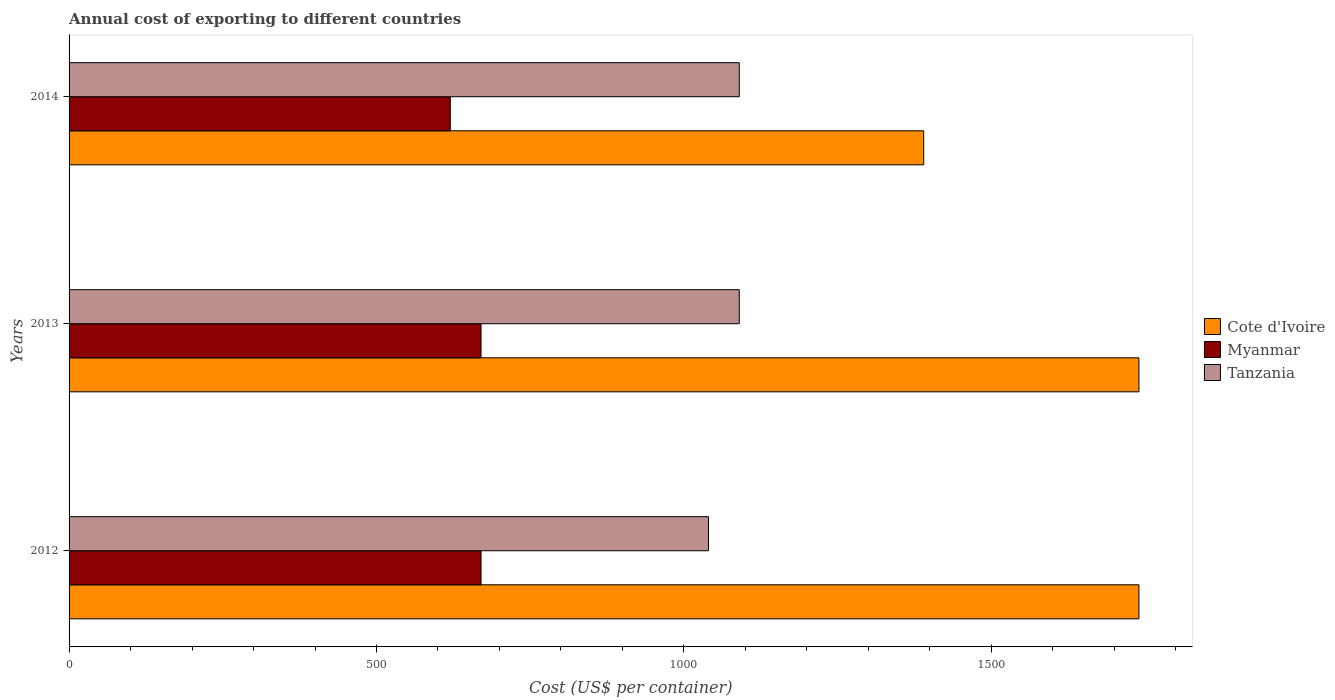What is the label of the 3rd group of bars from the top?
Offer a terse response. 2012. In how many cases, is the number of bars for a given year not equal to the number of legend labels?
Provide a succinct answer. 0. What is the total annual cost of exporting in Cote d'Ivoire in 2013?
Keep it short and to the point. 1740. Across all years, what is the maximum total annual cost of exporting in Tanzania?
Ensure brevity in your answer.  1090. Across all years, what is the minimum total annual cost of exporting in Myanmar?
Make the answer very short. 620. In which year was the total annual cost of exporting in Cote d'Ivoire minimum?
Provide a succinct answer. 2014. What is the total total annual cost of exporting in Cote d'Ivoire in the graph?
Offer a terse response. 4870. What is the difference between the total annual cost of exporting in Tanzania in 2012 and that in 2013?
Your response must be concise. -50. What is the difference between the total annual cost of exporting in Myanmar in 2014 and the total annual cost of exporting in Cote d'Ivoire in 2012?
Offer a terse response. -1120. What is the average total annual cost of exporting in Myanmar per year?
Offer a terse response. 653.33. In the year 2014, what is the difference between the total annual cost of exporting in Myanmar and total annual cost of exporting in Cote d'Ivoire?
Provide a short and direct response. -770. In how many years, is the total annual cost of exporting in Cote d'Ivoire greater than 200 US$?
Keep it short and to the point. 3. What is the ratio of the total annual cost of exporting in Myanmar in 2013 to that in 2014?
Your response must be concise. 1.08. What is the difference between the highest and the lowest total annual cost of exporting in Cote d'Ivoire?
Keep it short and to the point. 350. Is the sum of the total annual cost of exporting in Tanzania in 2012 and 2013 greater than the maximum total annual cost of exporting in Cote d'Ivoire across all years?
Keep it short and to the point. Yes. What does the 2nd bar from the top in 2012 represents?
Your answer should be very brief. Myanmar. What does the 3rd bar from the bottom in 2014 represents?
Ensure brevity in your answer.  Tanzania. How many bars are there?
Ensure brevity in your answer.  9. What is the difference between two consecutive major ticks on the X-axis?
Give a very brief answer. 500. Does the graph contain any zero values?
Provide a short and direct response. No. How many legend labels are there?
Your answer should be very brief. 3. What is the title of the graph?
Your response must be concise. Annual cost of exporting to different countries. Does "Somalia" appear as one of the legend labels in the graph?
Give a very brief answer. No. What is the label or title of the X-axis?
Your answer should be compact. Cost (US$ per container). What is the Cost (US$ per container) of Cote d'Ivoire in 2012?
Your answer should be compact. 1740. What is the Cost (US$ per container) of Myanmar in 2012?
Your response must be concise. 670. What is the Cost (US$ per container) of Tanzania in 2012?
Give a very brief answer. 1040. What is the Cost (US$ per container) in Cote d'Ivoire in 2013?
Ensure brevity in your answer.  1740. What is the Cost (US$ per container) in Myanmar in 2013?
Keep it short and to the point. 670. What is the Cost (US$ per container) in Tanzania in 2013?
Your answer should be very brief. 1090. What is the Cost (US$ per container) in Cote d'Ivoire in 2014?
Make the answer very short. 1390. What is the Cost (US$ per container) of Myanmar in 2014?
Ensure brevity in your answer.  620. What is the Cost (US$ per container) of Tanzania in 2014?
Offer a terse response. 1090. Across all years, what is the maximum Cost (US$ per container) in Cote d'Ivoire?
Offer a very short reply. 1740. Across all years, what is the maximum Cost (US$ per container) of Myanmar?
Provide a succinct answer. 670. Across all years, what is the maximum Cost (US$ per container) in Tanzania?
Make the answer very short. 1090. Across all years, what is the minimum Cost (US$ per container) in Cote d'Ivoire?
Keep it short and to the point. 1390. Across all years, what is the minimum Cost (US$ per container) in Myanmar?
Your answer should be very brief. 620. Across all years, what is the minimum Cost (US$ per container) in Tanzania?
Your answer should be compact. 1040. What is the total Cost (US$ per container) in Cote d'Ivoire in the graph?
Your answer should be very brief. 4870. What is the total Cost (US$ per container) of Myanmar in the graph?
Your answer should be very brief. 1960. What is the total Cost (US$ per container) in Tanzania in the graph?
Offer a very short reply. 3220. What is the difference between the Cost (US$ per container) of Tanzania in 2012 and that in 2013?
Make the answer very short. -50. What is the difference between the Cost (US$ per container) in Cote d'Ivoire in 2012 and that in 2014?
Provide a succinct answer. 350. What is the difference between the Cost (US$ per container) in Myanmar in 2012 and that in 2014?
Ensure brevity in your answer.  50. What is the difference between the Cost (US$ per container) of Cote d'Ivoire in 2013 and that in 2014?
Offer a very short reply. 350. What is the difference between the Cost (US$ per container) in Myanmar in 2013 and that in 2014?
Your answer should be very brief. 50. What is the difference between the Cost (US$ per container) of Tanzania in 2013 and that in 2014?
Keep it short and to the point. 0. What is the difference between the Cost (US$ per container) in Cote d'Ivoire in 2012 and the Cost (US$ per container) in Myanmar in 2013?
Your response must be concise. 1070. What is the difference between the Cost (US$ per container) of Cote d'Ivoire in 2012 and the Cost (US$ per container) of Tanzania in 2013?
Ensure brevity in your answer.  650. What is the difference between the Cost (US$ per container) in Myanmar in 2012 and the Cost (US$ per container) in Tanzania in 2013?
Ensure brevity in your answer.  -420. What is the difference between the Cost (US$ per container) of Cote d'Ivoire in 2012 and the Cost (US$ per container) of Myanmar in 2014?
Provide a short and direct response. 1120. What is the difference between the Cost (US$ per container) in Cote d'Ivoire in 2012 and the Cost (US$ per container) in Tanzania in 2014?
Offer a very short reply. 650. What is the difference between the Cost (US$ per container) of Myanmar in 2012 and the Cost (US$ per container) of Tanzania in 2014?
Offer a very short reply. -420. What is the difference between the Cost (US$ per container) of Cote d'Ivoire in 2013 and the Cost (US$ per container) of Myanmar in 2014?
Your answer should be compact. 1120. What is the difference between the Cost (US$ per container) in Cote d'Ivoire in 2013 and the Cost (US$ per container) in Tanzania in 2014?
Provide a short and direct response. 650. What is the difference between the Cost (US$ per container) in Myanmar in 2013 and the Cost (US$ per container) in Tanzania in 2014?
Ensure brevity in your answer.  -420. What is the average Cost (US$ per container) of Cote d'Ivoire per year?
Give a very brief answer. 1623.33. What is the average Cost (US$ per container) in Myanmar per year?
Offer a terse response. 653.33. What is the average Cost (US$ per container) of Tanzania per year?
Offer a very short reply. 1073.33. In the year 2012, what is the difference between the Cost (US$ per container) in Cote d'Ivoire and Cost (US$ per container) in Myanmar?
Your answer should be compact. 1070. In the year 2012, what is the difference between the Cost (US$ per container) in Cote d'Ivoire and Cost (US$ per container) in Tanzania?
Keep it short and to the point. 700. In the year 2012, what is the difference between the Cost (US$ per container) of Myanmar and Cost (US$ per container) of Tanzania?
Keep it short and to the point. -370. In the year 2013, what is the difference between the Cost (US$ per container) of Cote d'Ivoire and Cost (US$ per container) of Myanmar?
Keep it short and to the point. 1070. In the year 2013, what is the difference between the Cost (US$ per container) of Cote d'Ivoire and Cost (US$ per container) of Tanzania?
Offer a terse response. 650. In the year 2013, what is the difference between the Cost (US$ per container) in Myanmar and Cost (US$ per container) in Tanzania?
Keep it short and to the point. -420. In the year 2014, what is the difference between the Cost (US$ per container) of Cote d'Ivoire and Cost (US$ per container) of Myanmar?
Give a very brief answer. 770. In the year 2014, what is the difference between the Cost (US$ per container) in Cote d'Ivoire and Cost (US$ per container) in Tanzania?
Ensure brevity in your answer.  300. In the year 2014, what is the difference between the Cost (US$ per container) of Myanmar and Cost (US$ per container) of Tanzania?
Your answer should be compact. -470. What is the ratio of the Cost (US$ per container) of Myanmar in 2012 to that in 2013?
Your answer should be compact. 1. What is the ratio of the Cost (US$ per container) in Tanzania in 2012 to that in 2013?
Offer a terse response. 0.95. What is the ratio of the Cost (US$ per container) in Cote d'Ivoire in 2012 to that in 2014?
Your response must be concise. 1.25. What is the ratio of the Cost (US$ per container) of Myanmar in 2012 to that in 2014?
Your answer should be compact. 1.08. What is the ratio of the Cost (US$ per container) in Tanzania in 2012 to that in 2014?
Your answer should be very brief. 0.95. What is the ratio of the Cost (US$ per container) of Cote d'Ivoire in 2013 to that in 2014?
Your response must be concise. 1.25. What is the ratio of the Cost (US$ per container) of Myanmar in 2013 to that in 2014?
Provide a succinct answer. 1.08. What is the ratio of the Cost (US$ per container) of Tanzania in 2013 to that in 2014?
Your answer should be very brief. 1. What is the difference between the highest and the lowest Cost (US$ per container) in Cote d'Ivoire?
Offer a very short reply. 350. What is the difference between the highest and the lowest Cost (US$ per container) in Tanzania?
Give a very brief answer. 50. 